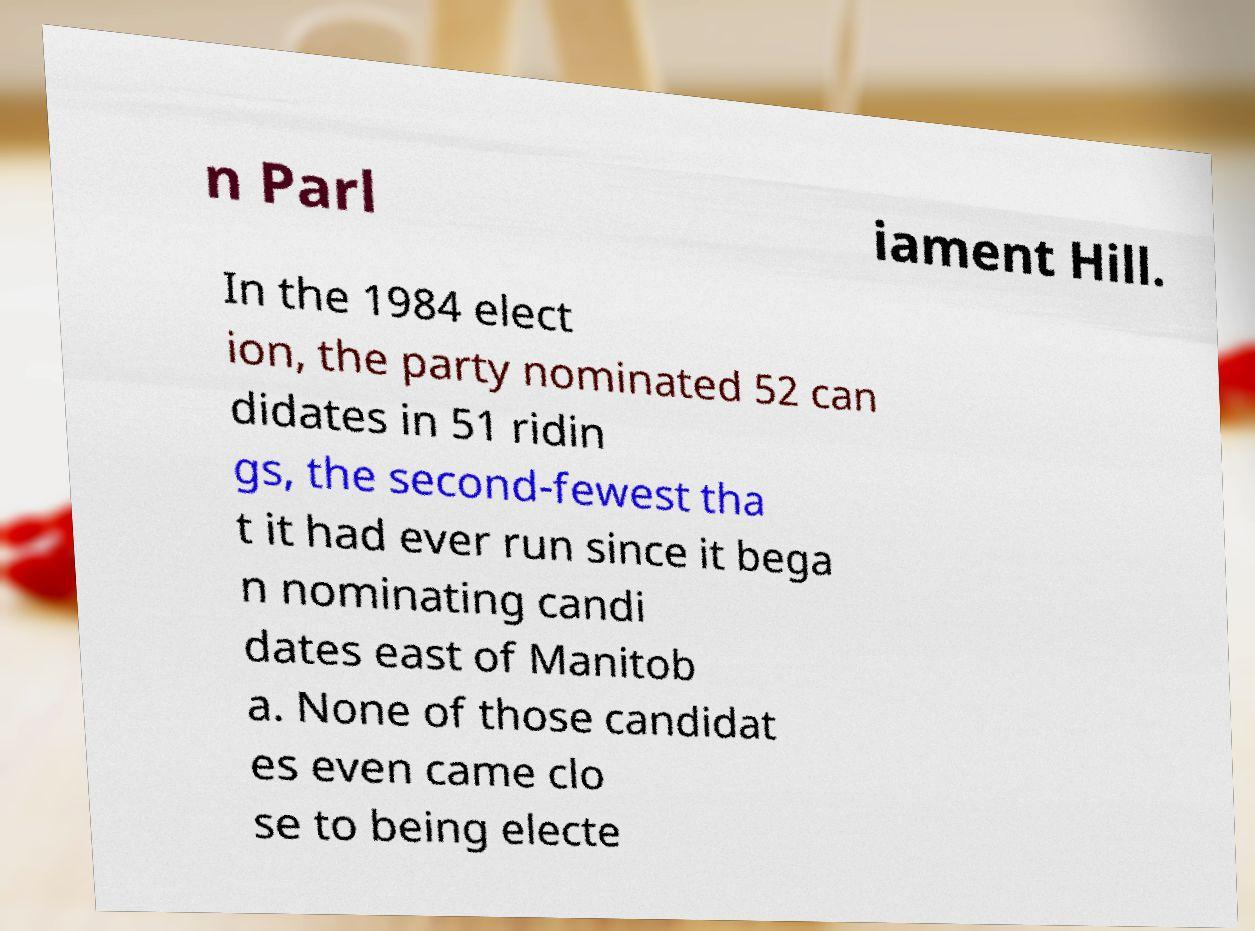Can you read and provide the text displayed in the image?This photo seems to have some interesting text. Can you extract and type it out for me? n Parl iament Hill. In the 1984 elect ion, the party nominated 52 can didates in 51 ridin gs, the second-fewest tha t it had ever run since it bega n nominating candi dates east of Manitob a. None of those candidat es even came clo se to being electe 